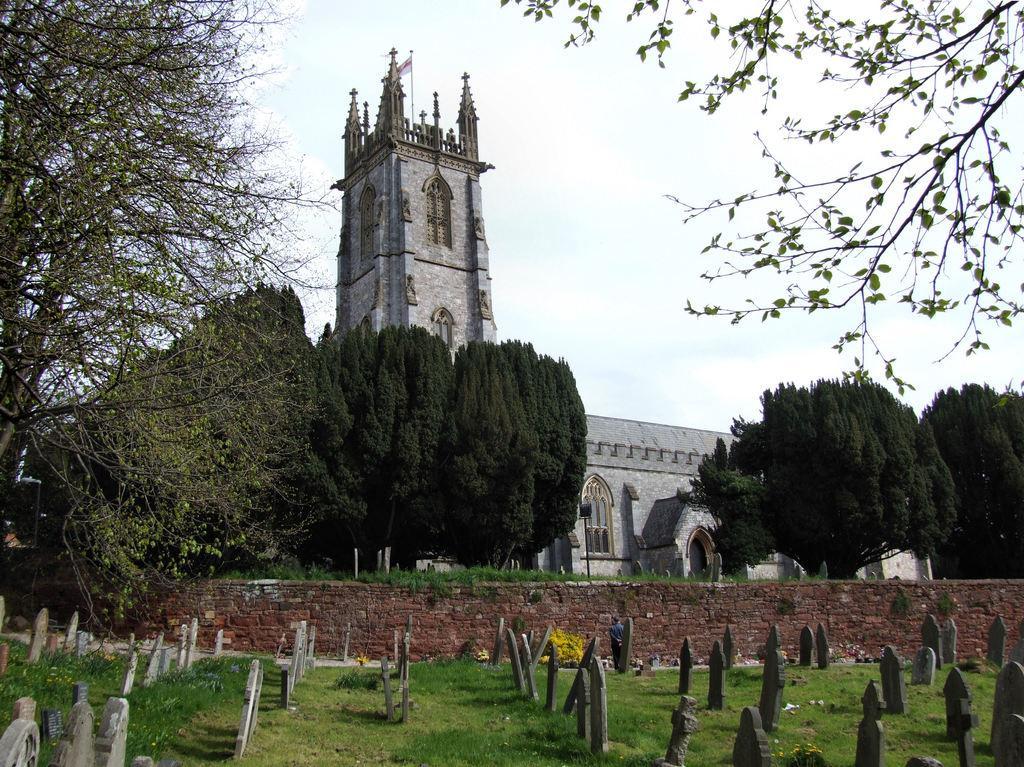Describe this image in one or two sentences. In this picture we can see graves, wall, trees, building with windows and in the background we can see the sky with clouds. 